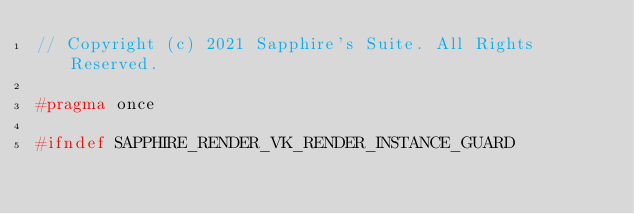<code> <loc_0><loc_0><loc_500><loc_500><_C++_>// Copyright (c) 2021 Sapphire's Suite. All Rights Reserved.

#pragma once

#ifndef SAPPHIRE_RENDER_VK_RENDER_INSTANCE_GUARD</code> 